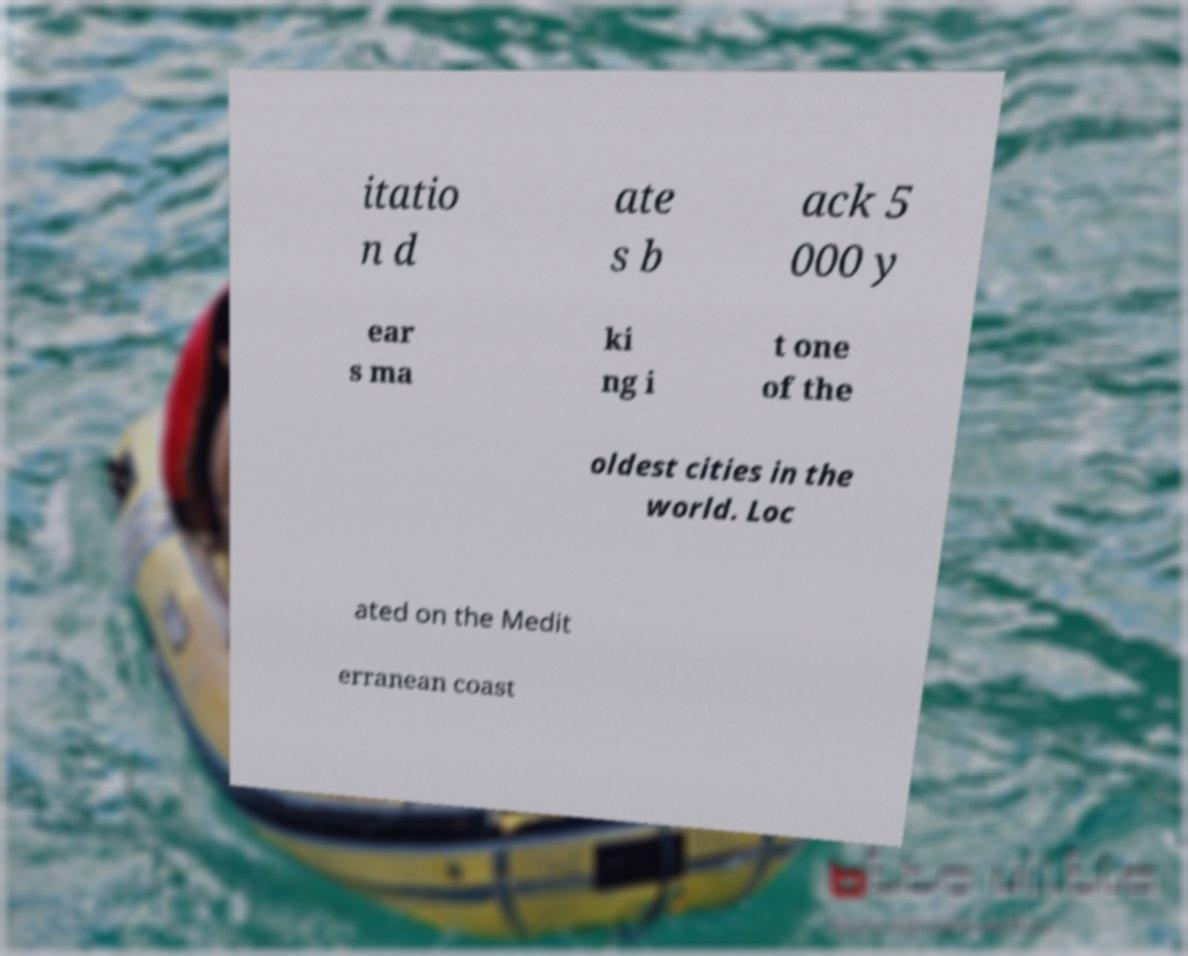Please read and relay the text visible in this image. What does it say? itatio n d ate s b ack 5 000 y ear s ma ki ng i t one of the oldest cities in the world. Loc ated on the Medit erranean coast 